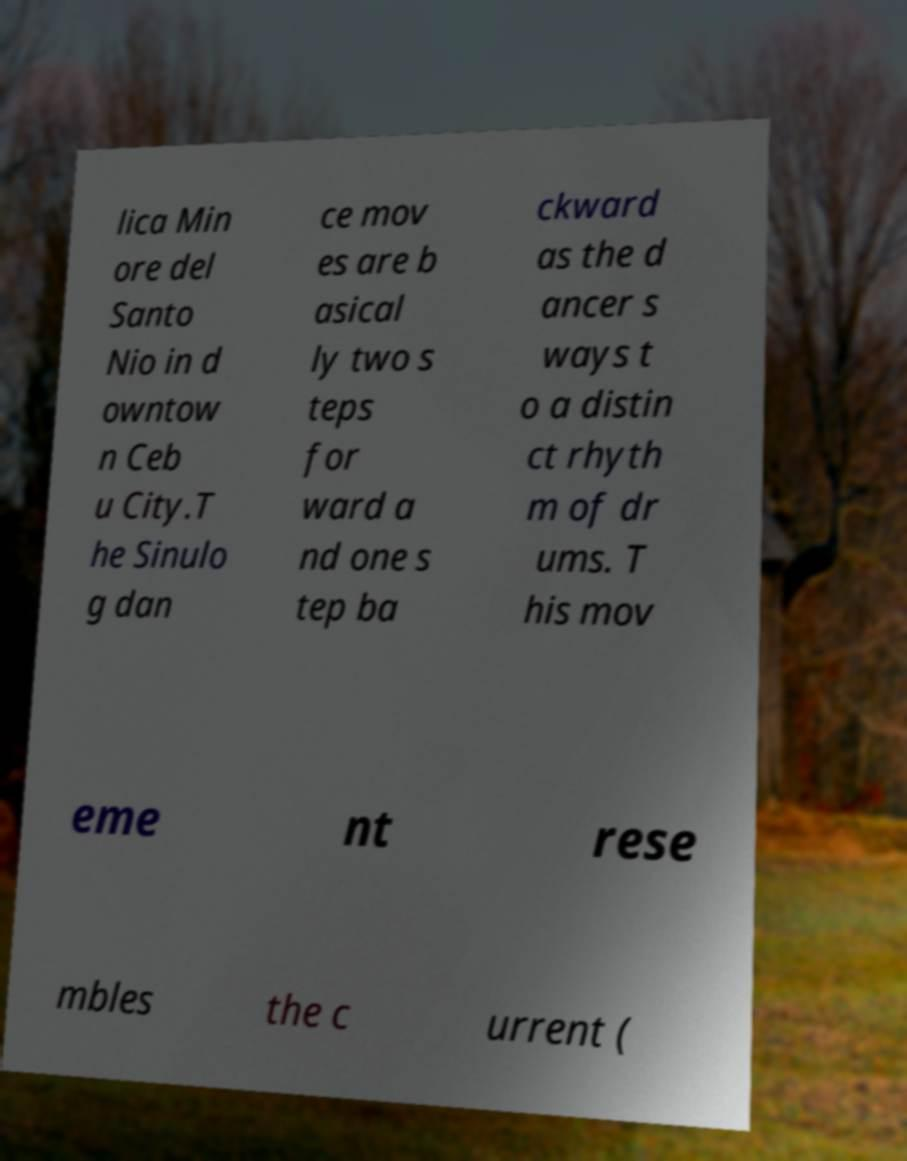Could you extract and type out the text from this image? lica Min ore del Santo Nio in d owntow n Ceb u City.T he Sinulo g dan ce mov es are b asical ly two s teps for ward a nd one s tep ba ckward as the d ancer s ways t o a distin ct rhyth m of dr ums. T his mov eme nt rese mbles the c urrent ( 